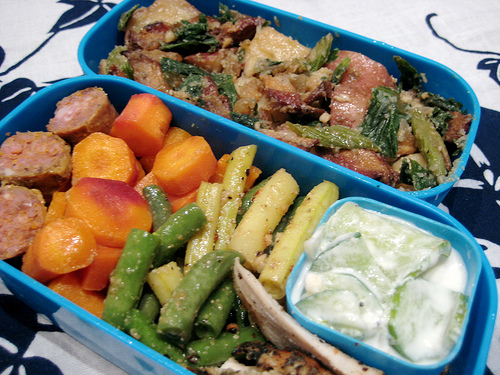<image>
Can you confirm if the carrots is to the right of the green beans? No. The carrots is not to the right of the green beans. The horizontal positioning shows a different relationship. 